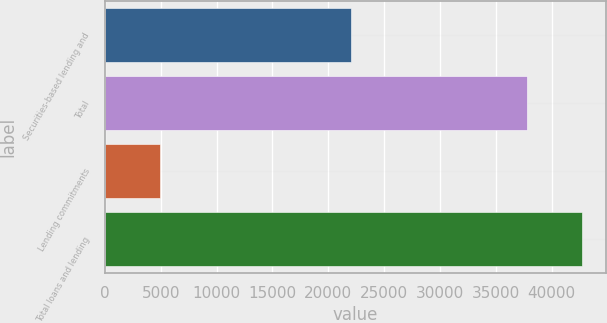<chart> <loc_0><loc_0><loc_500><loc_500><bar_chart><fcel>Securities-based lending and<fcel>Total<fcel>Lending commitments<fcel>Total loans and lending<nl><fcel>21997<fcel>37822<fcel>4914<fcel>42736<nl></chart> 